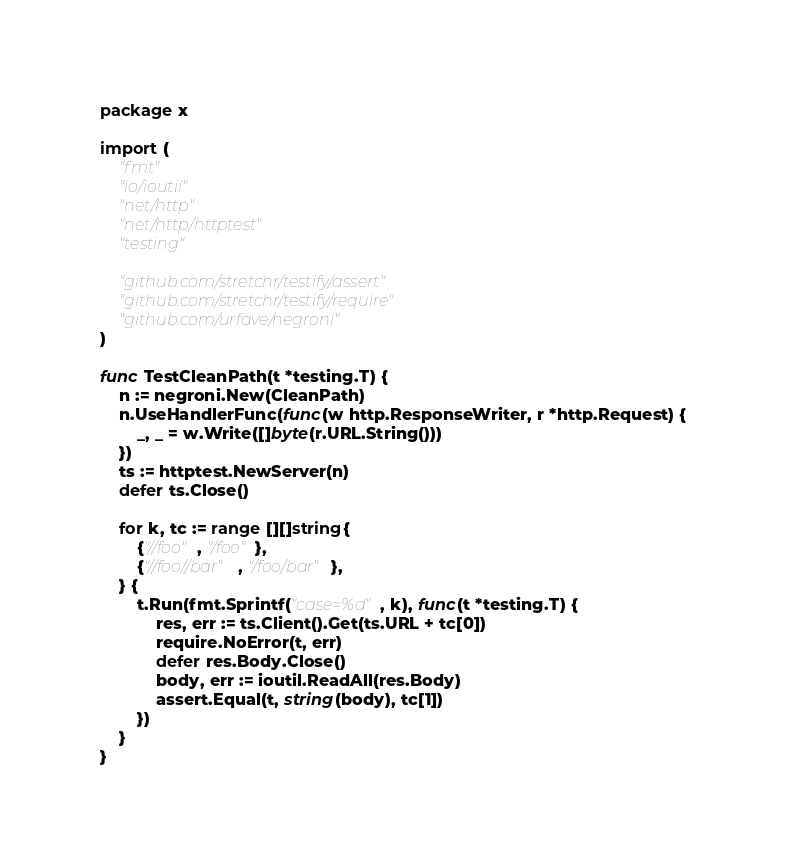<code> <loc_0><loc_0><loc_500><loc_500><_Go_>package x

import (
	"fmt"
	"io/ioutil"
	"net/http"
	"net/http/httptest"
	"testing"

	"github.com/stretchr/testify/assert"
	"github.com/stretchr/testify/require"
	"github.com/urfave/negroni"
)

func TestCleanPath(t *testing.T) {
	n := negroni.New(CleanPath)
	n.UseHandlerFunc(func(w http.ResponseWriter, r *http.Request) {
		_, _ = w.Write([]byte(r.URL.String()))
	})
	ts := httptest.NewServer(n)
	defer ts.Close()

	for k, tc := range [][]string{
		{"//foo", "/foo"},
		{"//foo//bar", "/foo/bar"},
	} {
		t.Run(fmt.Sprintf("case=%d", k), func(t *testing.T) {
			res, err := ts.Client().Get(ts.URL + tc[0])
			require.NoError(t, err)
			defer res.Body.Close()
			body, err := ioutil.ReadAll(res.Body)
			assert.Equal(t, string(body), tc[1])
		})
	}
}
</code> 